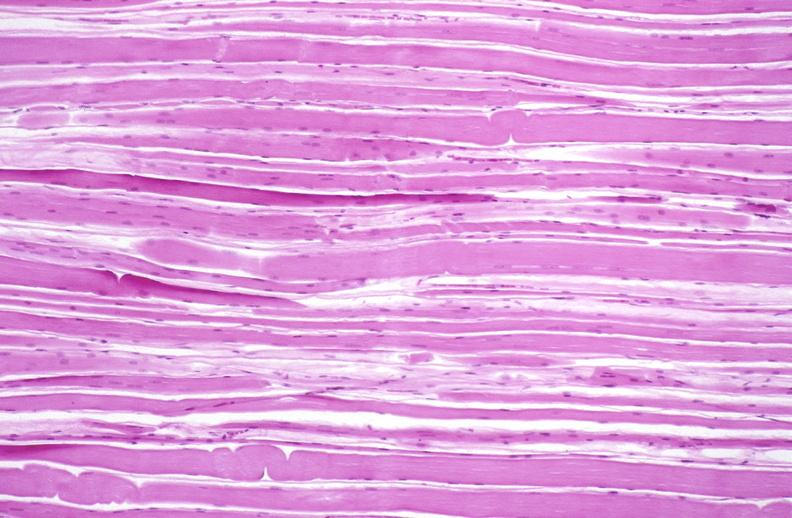does exposure show skeletal muscle atrophy?
Answer the question using a single word or phrase. No 